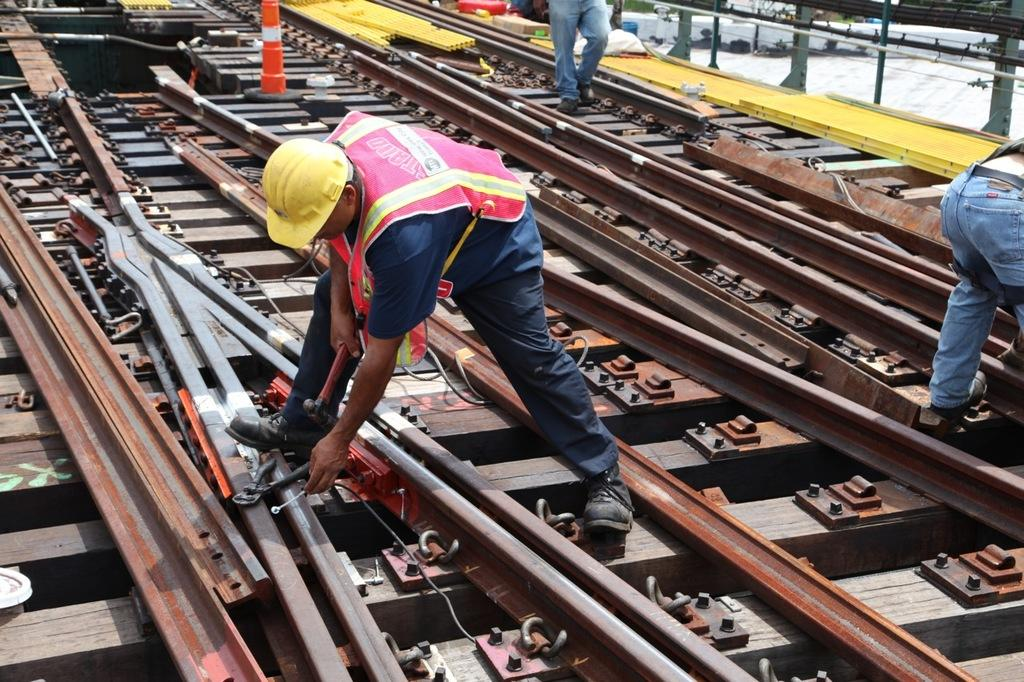What can be seen in the image that is related to transportation? There are railway tracks in the image. How many people are present in the image? There are three persons in the image. What are the people doing in the image? One person is repairing a railway track. What can be seen in the background of the image? There are objects visible in the background of the image. What type of hate is being distributed by the person repairing the railway track in the image? There is no mention of hate or distribution in the image; the person is simply repairing a railway track. 